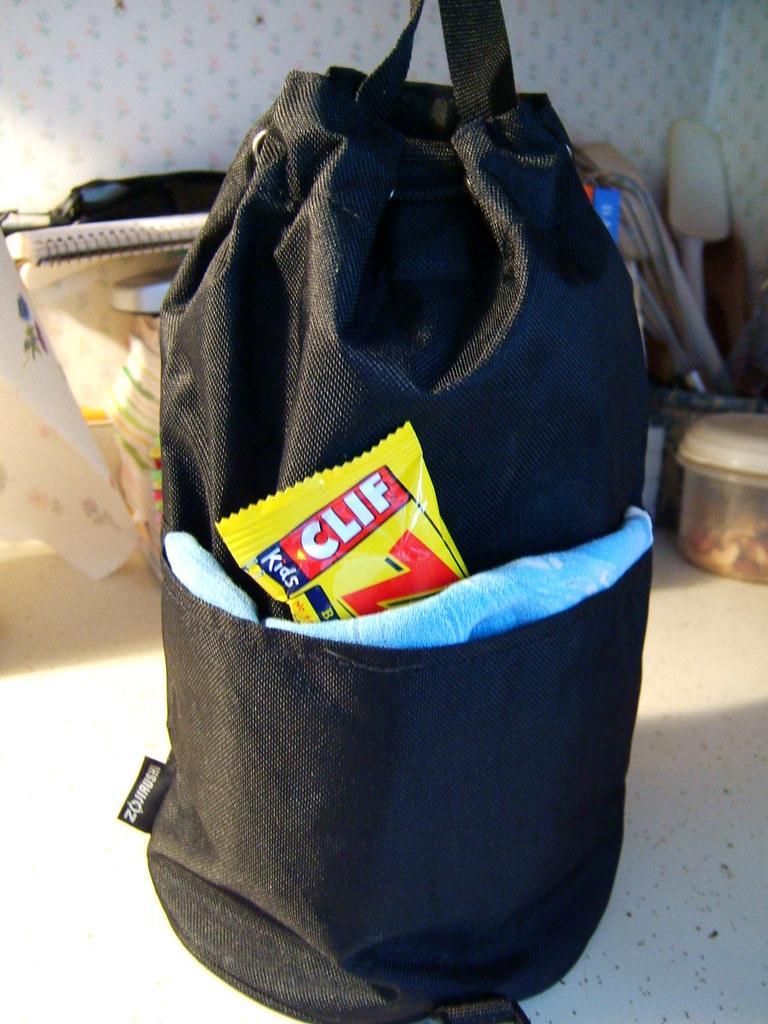Can you describe this image briefly? In this picture, we see a black bag in which yellow cover and blue cloth is placed. Behind that, we see book, white cloth, plastic box are placed on a table and behind that, we see a white wall. 